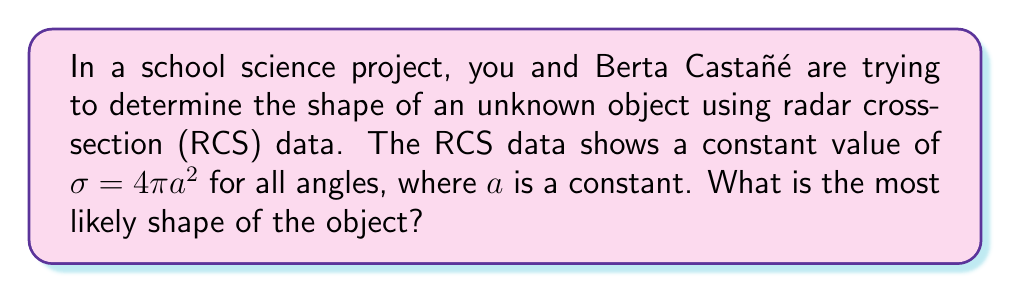Give your solution to this math problem. Let's approach this step-by-step:

1) The radar cross-section (RCS) is a measure of how detectable an object is with radar. It's defined as the projected area of a perfectly reflecting sphere that would produce the same radar return as the target.

2) The given RCS formula $\sigma = 4\pi a^2$ is significant because:
   a) It's constant for all angles
   b) It has the form of the surface area of a sphere

3) For a sphere with radius $r$, the RCS is given by:
   $$\sigma_{sphere} = \pi r^2$$
   when $r$ is much larger than the radar wavelength.

4) Comparing this to our given formula:
   $$4\pi a^2 = \pi r^2$$

5) Solving for $r$:
   $$r^2 = 4a^2$$
   $$r = 2a$$

6) This means our object has an RCS equivalent to a sphere with radius $2a$.

7) The key point is that the RCS is constant for all angles. This is a unique property of spheres in radar detection.

8) Other shapes would typically have varying RCS values depending on the angle of observation.

Therefore, given the constant RCS value for all angles, the most likely shape of the object is a sphere.
Answer: Sphere 